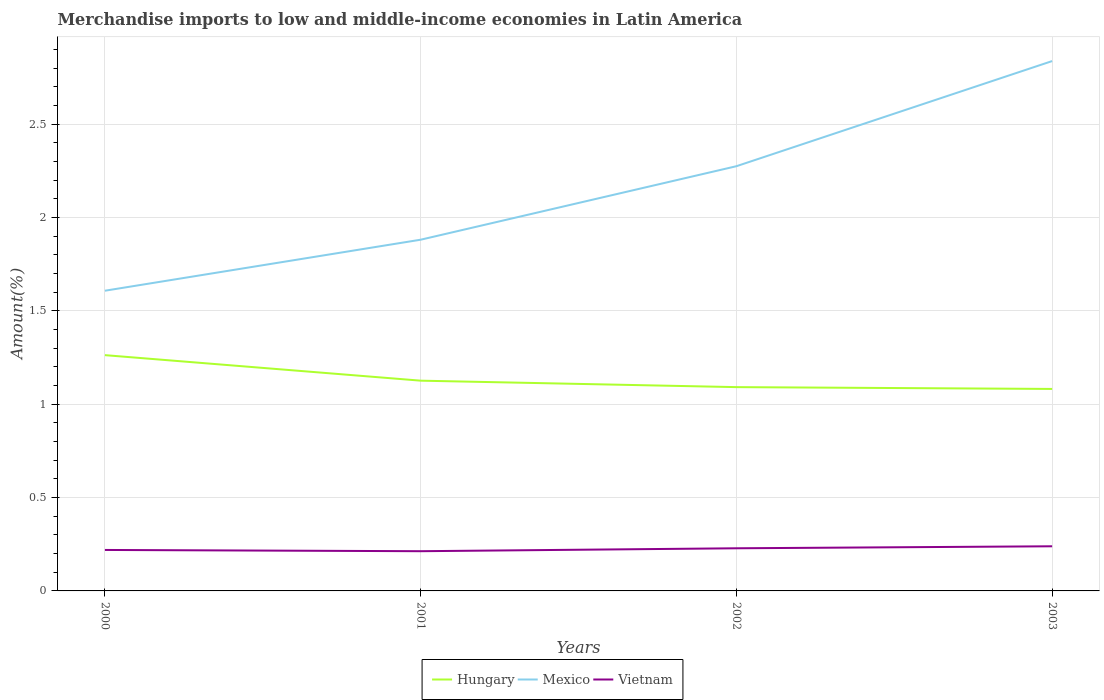How many different coloured lines are there?
Provide a short and direct response. 3. Does the line corresponding to Vietnam intersect with the line corresponding to Hungary?
Your answer should be compact. No. Across all years, what is the maximum percentage of amount earned from merchandise imports in Hungary?
Offer a terse response. 1.08. What is the total percentage of amount earned from merchandise imports in Mexico in the graph?
Keep it short and to the point. -0.56. What is the difference between the highest and the second highest percentage of amount earned from merchandise imports in Hungary?
Offer a terse response. 0.18. Is the percentage of amount earned from merchandise imports in Vietnam strictly greater than the percentage of amount earned from merchandise imports in Hungary over the years?
Keep it short and to the point. Yes. How many lines are there?
Give a very brief answer. 3. How many years are there in the graph?
Your response must be concise. 4. What is the title of the graph?
Ensure brevity in your answer.  Merchandise imports to low and middle-income economies in Latin America. Does "West Bank and Gaza" appear as one of the legend labels in the graph?
Provide a short and direct response. No. What is the label or title of the Y-axis?
Keep it short and to the point. Amount(%). What is the Amount(%) of Hungary in 2000?
Ensure brevity in your answer.  1.26. What is the Amount(%) in Mexico in 2000?
Provide a short and direct response. 1.61. What is the Amount(%) of Vietnam in 2000?
Ensure brevity in your answer.  0.22. What is the Amount(%) of Hungary in 2001?
Offer a very short reply. 1.13. What is the Amount(%) in Mexico in 2001?
Provide a succinct answer. 1.88. What is the Amount(%) in Vietnam in 2001?
Your answer should be very brief. 0.21. What is the Amount(%) in Hungary in 2002?
Your answer should be very brief. 1.09. What is the Amount(%) of Mexico in 2002?
Offer a very short reply. 2.27. What is the Amount(%) in Vietnam in 2002?
Your response must be concise. 0.23. What is the Amount(%) in Hungary in 2003?
Make the answer very short. 1.08. What is the Amount(%) of Mexico in 2003?
Keep it short and to the point. 2.84. What is the Amount(%) of Vietnam in 2003?
Make the answer very short. 0.24. Across all years, what is the maximum Amount(%) of Hungary?
Give a very brief answer. 1.26. Across all years, what is the maximum Amount(%) in Mexico?
Your answer should be compact. 2.84. Across all years, what is the maximum Amount(%) of Vietnam?
Make the answer very short. 0.24. Across all years, what is the minimum Amount(%) in Hungary?
Make the answer very short. 1.08. Across all years, what is the minimum Amount(%) in Mexico?
Make the answer very short. 1.61. Across all years, what is the minimum Amount(%) of Vietnam?
Your answer should be very brief. 0.21. What is the total Amount(%) in Hungary in the graph?
Your answer should be compact. 4.56. What is the total Amount(%) of Mexico in the graph?
Make the answer very short. 8.6. What is the total Amount(%) in Vietnam in the graph?
Give a very brief answer. 0.9. What is the difference between the Amount(%) in Hungary in 2000 and that in 2001?
Your answer should be compact. 0.14. What is the difference between the Amount(%) of Mexico in 2000 and that in 2001?
Keep it short and to the point. -0.27. What is the difference between the Amount(%) in Vietnam in 2000 and that in 2001?
Offer a very short reply. 0.01. What is the difference between the Amount(%) in Hungary in 2000 and that in 2002?
Ensure brevity in your answer.  0.17. What is the difference between the Amount(%) in Mexico in 2000 and that in 2002?
Offer a terse response. -0.67. What is the difference between the Amount(%) of Vietnam in 2000 and that in 2002?
Make the answer very short. -0.01. What is the difference between the Amount(%) of Hungary in 2000 and that in 2003?
Keep it short and to the point. 0.18. What is the difference between the Amount(%) in Mexico in 2000 and that in 2003?
Your answer should be compact. -1.23. What is the difference between the Amount(%) in Vietnam in 2000 and that in 2003?
Your answer should be compact. -0.02. What is the difference between the Amount(%) in Hungary in 2001 and that in 2002?
Provide a short and direct response. 0.03. What is the difference between the Amount(%) of Mexico in 2001 and that in 2002?
Provide a succinct answer. -0.39. What is the difference between the Amount(%) of Vietnam in 2001 and that in 2002?
Make the answer very short. -0.02. What is the difference between the Amount(%) of Hungary in 2001 and that in 2003?
Offer a very short reply. 0.04. What is the difference between the Amount(%) in Mexico in 2001 and that in 2003?
Offer a terse response. -0.96. What is the difference between the Amount(%) of Vietnam in 2001 and that in 2003?
Provide a short and direct response. -0.03. What is the difference between the Amount(%) of Hungary in 2002 and that in 2003?
Your response must be concise. 0.01. What is the difference between the Amount(%) of Mexico in 2002 and that in 2003?
Your answer should be compact. -0.56. What is the difference between the Amount(%) of Vietnam in 2002 and that in 2003?
Your response must be concise. -0.01. What is the difference between the Amount(%) in Hungary in 2000 and the Amount(%) in Mexico in 2001?
Provide a short and direct response. -0.62. What is the difference between the Amount(%) in Hungary in 2000 and the Amount(%) in Vietnam in 2001?
Make the answer very short. 1.05. What is the difference between the Amount(%) of Mexico in 2000 and the Amount(%) of Vietnam in 2001?
Make the answer very short. 1.4. What is the difference between the Amount(%) of Hungary in 2000 and the Amount(%) of Mexico in 2002?
Your answer should be compact. -1.01. What is the difference between the Amount(%) of Hungary in 2000 and the Amount(%) of Vietnam in 2002?
Give a very brief answer. 1.03. What is the difference between the Amount(%) in Mexico in 2000 and the Amount(%) in Vietnam in 2002?
Ensure brevity in your answer.  1.38. What is the difference between the Amount(%) of Hungary in 2000 and the Amount(%) of Mexico in 2003?
Give a very brief answer. -1.58. What is the difference between the Amount(%) in Hungary in 2000 and the Amount(%) in Vietnam in 2003?
Keep it short and to the point. 1.02. What is the difference between the Amount(%) of Mexico in 2000 and the Amount(%) of Vietnam in 2003?
Offer a very short reply. 1.37. What is the difference between the Amount(%) in Hungary in 2001 and the Amount(%) in Mexico in 2002?
Keep it short and to the point. -1.15. What is the difference between the Amount(%) of Hungary in 2001 and the Amount(%) of Vietnam in 2002?
Your response must be concise. 0.9. What is the difference between the Amount(%) in Mexico in 2001 and the Amount(%) in Vietnam in 2002?
Your response must be concise. 1.65. What is the difference between the Amount(%) of Hungary in 2001 and the Amount(%) of Mexico in 2003?
Provide a short and direct response. -1.71. What is the difference between the Amount(%) of Hungary in 2001 and the Amount(%) of Vietnam in 2003?
Make the answer very short. 0.89. What is the difference between the Amount(%) of Mexico in 2001 and the Amount(%) of Vietnam in 2003?
Keep it short and to the point. 1.64. What is the difference between the Amount(%) in Hungary in 2002 and the Amount(%) in Mexico in 2003?
Your answer should be very brief. -1.75. What is the difference between the Amount(%) of Hungary in 2002 and the Amount(%) of Vietnam in 2003?
Offer a terse response. 0.85. What is the difference between the Amount(%) in Mexico in 2002 and the Amount(%) in Vietnam in 2003?
Keep it short and to the point. 2.04. What is the average Amount(%) of Hungary per year?
Your answer should be compact. 1.14. What is the average Amount(%) in Mexico per year?
Keep it short and to the point. 2.15. What is the average Amount(%) of Vietnam per year?
Ensure brevity in your answer.  0.22. In the year 2000, what is the difference between the Amount(%) of Hungary and Amount(%) of Mexico?
Your answer should be compact. -0.35. In the year 2000, what is the difference between the Amount(%) in Hungary and Amount(%) in Vietnam?
Ensure brevity in your answer.  1.04. In the year 2000, what is the difference between the Amount(%) of Mexico and Amount(%) of Vietnam?
Your answer should be very brief. 1.39. In the year 2001, what is the difference between the Amount(%) in Hungary and Amount(%) in Mexico?
Provide a succinct answer. -0.76. In the year 2001, what is the difference between the Amount(%) of Hungary and Amount(%) of Vietnam?
Give a very brief answer. 0.91. In the year 2001, what is the difference between the Amount(%) of Mexico and Amount(%) of Vietnam?
Your response must be concise. 1.67. In the year 2002, what is the difference between the Amount(%) in Hungary and Amount(%) in Mexico?
Ensure brevity in your answer.  -1.18. In the year 2002, what is the difference between the Amount(%) in Hungary and Amount(%) in Vietnam?
Ensure brevity in your answer.  0.86. In the year 2002, what is the difference between the Amount(%) in Mexico and Amount(%) in Vietnam?
Ensure brevity in your answer.  2.05. In the year 2003, what is the difference between the Amount(%) in Hungary and Amount(%) in Mexico?
Give a very brief answer. -1.76. In the year 2003, what is the difference between the Amount(%) of Hungary and Amount(%) of Vietnam?
Provide a short and direct response. 0.84. In the year 2003, what is the difference between the Amount(%) of Mexico and Amount(%) of Vietnam?
Offer a terse response. 2.6. What is the ratio of the Amount(%) of Hungary in 2000 to that in 2001?
Keep it short and to the point. 1.12. What is the ratio of the Amount(%) of Mexico in 2000 to that in 2001?
Provide a short and direct response. 0.85. What is the ratio of the Amount(%) of Vietnam in 2000 to that in 2001?
Offer a very short reply. 1.03. What is the ratio of the Amount(%) in Hungary in 2000 to that in 2002?
Make the answer very short. 1.16. What is the ratio of the Amount(%) in Mexico in 2000 to that in 2002?
Offer a very short reply. 0.71. What is the ratio of the Amount(%) of Vietnam in 2000 to that in 2002?
Your answer should be very brief. 0.96. What is the ratio of the Amount(%) of Hungary in 2000 to that in 2003?
Keep it short and to the point. 1.17. What is the ratio of the Amount(%) of Mexico in 2000 to that in 2003?
Your response must be concise. 0.57. What is the ratio of the Amount(%) of Vietnam in 2000 to that in 2003?
Offer a very short reply. 0.92. What is the ratio of the Amount(%) of Hungary in 2001 to that in 2002?
Make the answer very short. 1.03. What is the ratio of the Amount(%) in Mexico in 2001 to that in 2002?
Your answer should be very brief. 0.83. What is the ratio of the Amount(%) of Vietnam in 2001 to that in 2002?
Your answer should be very brief. 0.93. What is the ratio of the Amount(%) in Hungary in 2001 to that in 2003?
Give a very brief answer. 1.04. What is the ratio of the Amount(%) in Mexico in 2001 to that in 2003?
Provide a succinct answer. 0.66. What is the ratio of the Amount(%) in Vietnam in 2001 to that in 2003?
Offer a very short reply. 0.89. What is the ratio of the Amount(%) in Mexico in 2002 to that in 2003?
Give a very brief answer. 0.8. What is the ratio of the Amount(%) in Vietnam in 2002 to that in 2003?
Make the answer very short. 0.96. What is the difference between the highest and the second highest Amount(%) in Hungary?
Offer a very short reply. 0.14. What is the difference between the highest and the second highest Amount(%) in Mexico?
Your answer should be compact. 0.56. What is the difference between the highest and the second highest Amount(%) in Vietnam?
Your response must be concise. 0.01. What is the difference between the highest and the lowest Amount(%) of Hungary?
Offer a terse response. 0.18. What is the difference between the highest and the lowest Amount(%) in Mexico?
Provide a short and direct response. 1.23. What is the difference between the highest and the lowest Amount(%) in Vietnam?
Ensure brevity in your answer.  0.03. 